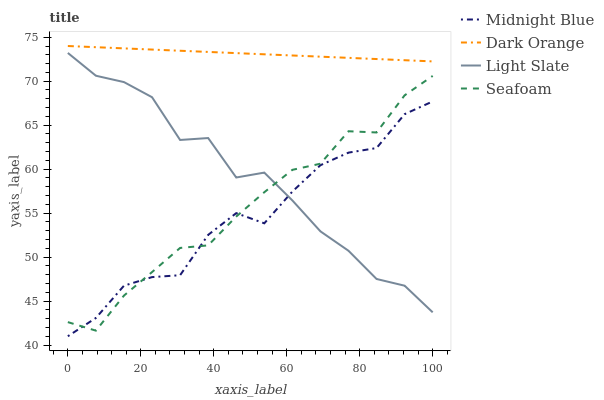Does Midnight Blue have the minimum area under the curve?
Answer yes or no. Yes. Does Dark Orange have the maximum area under the curve?
Answer yes or no. Yes. Does Dark Orange have the minimum area under the curve?
Answer yes or no. No. Does Midnight Blue have the maximum area under the curve?
Answer yes or no. No. Is Dark Orange the smoothest?
Answer yes or no. Yes. Is Light Slate the roughest?
Answer yes or no. Yes. Is Midnight Blue the smoothest?
Answer yes or no. No. Is Midnight Blue the roughest?
Answer yes or no. No. Does Midnight Blue have the lowest value?
Answer yes or no. Yes. Does Dark Orange have the lowest value?
Answer yes or no. No. Does Dark Orange have the highest value?
Answer yes or no. Yes. Does Midnight Blue have the highest value?
Answer yes or no. No. Is Seafoam less than Dark Orange?
Answer yes or no. Yes. Is Dark Orange greater than Light Slate?
Answer yes or no. Yes. Does Midnight Blue intersect Light Slate?
Answer yes or no. Yes. Is Midnight Blue less than Light Slate?
Answer yes or no. No. Is Midnight Blue greater than Light Slate?
Answer yes or no. No. Does Seafoam intersect Dark Orange?
Answer yes or no. No. 